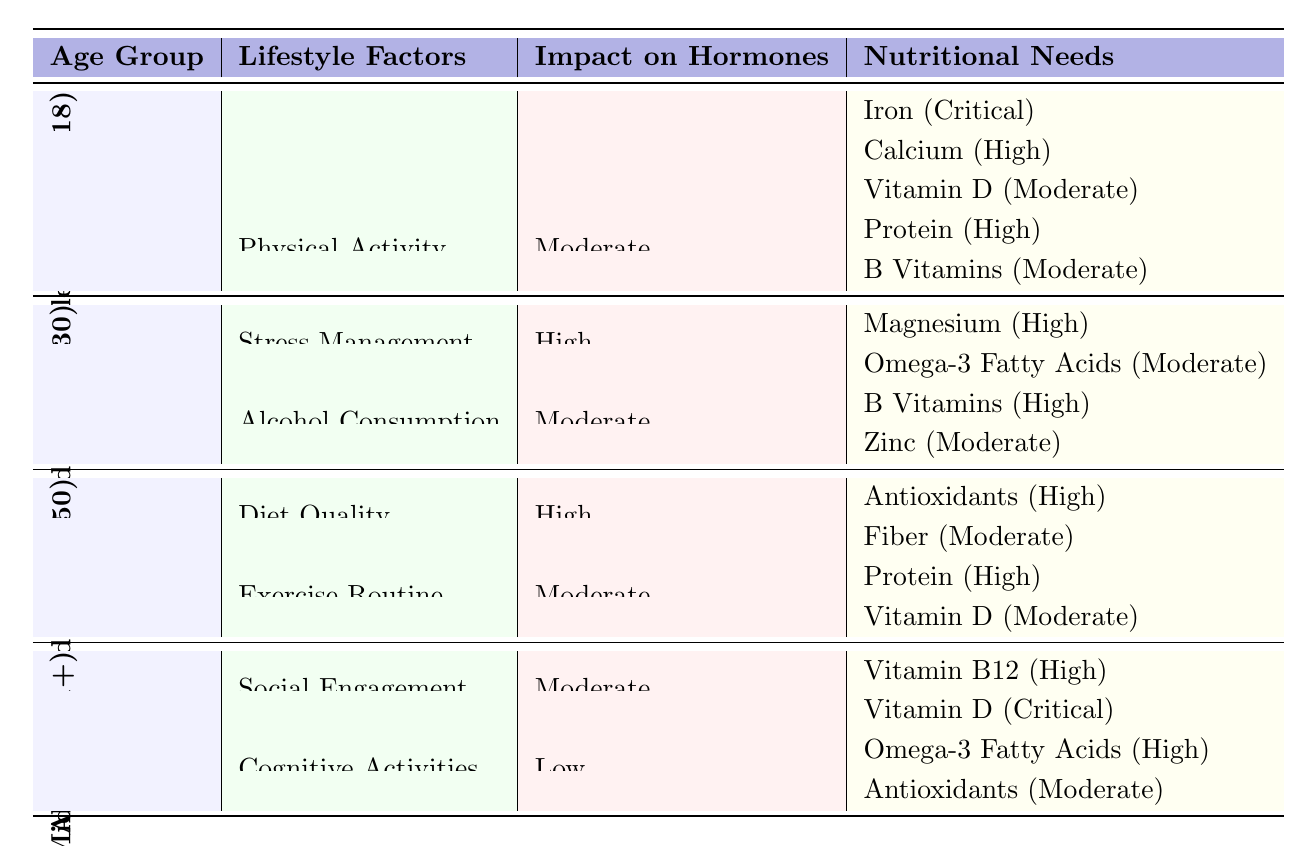What lifestyle factor has a high impact on hormone levels for adolescents? The table shows that "Sleep Duration" is a lifestyle factor with a high impact on hormones for the adolescents age group.
Answer: Sleep Duration Which nutrients are critical for adolescents according to the table? The table lists three nutritional needs for adolescents: Iron (Critical), Calcium (High), and Vitamin D (Moderate). Therefore, Iron is marked as critical.
Answer: Iron Do older adults have a high impact from cognitive activities on their hormone levels? According to the table, cognitive activities have a low impact on hormone levels for older adults, indicating the answer is no.
Answer: No What is the significance of Vitamin D for older adults? The table indicates that Vitamin D is critical for older adults, highlighting its importance for this age group.
Answer: Critical For middle-aged adults, which lifestyle factor has the highest impact on hormone levels? The table indicates that "Diet Quality" is listed as having a high impact on hormone levels for middle-aged adults.
Answer: Diet Quality What is the difference in hormone levels impacting lifestyle factors between young adults and adolescents? Young adults experience the impact of "Stress Management" and "Alcohol Consumption" significantly on their hormones compared to adolescents, who are primarily impacted by "Sleep Duration" and "Physical Activity."
Answer: Stress Management and Alcohol Consumption Which nutrients have a high importance level for nutritional needs in young adults? For young adults, the nutrients with high importance are Magnesium (from Stress Management) and B Vitamins (from Alcohol Consumption).
Answer: Magnesium and B Vitamins What hormone levels are declining for middle-aged women according to the data? The data shows that "Estrogen" levels are declining for middle-aged women.
Answer: Estrogen Is Protein important for dietary needs across all age groups listed in the table? The table reveals that Protein is listed as high importance for adolescents and middle-aged adults but does not mention its importance for other age groups, indicating it is not universally important.
Answer: No How do the nutritional needs of older adults differ from those of young adults? The nutritional needs for older adults include Vitamin B12 (High) and Vitamin D (Critical), while young adults focus on Magnesium (High) and B Vitamins (High). This indicates different nutritional priorities based on age groups.
Answer: Different nutrients highlighted 